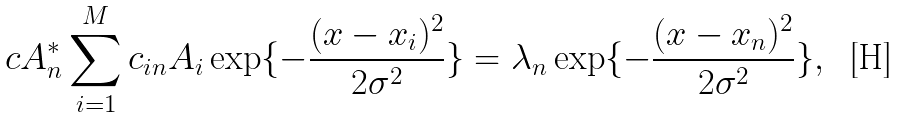Convert formula to latex. <formula><loc_0><loc_0><loc_500><loc_500>c A _ { n } ^ { * } \sum _ { i = 1 } ^ { M } c _ { i n } A _ { i } \exp \{ - \frac { ( x - x _ { i } ) ^ { 2 } } { 2 \sigma ^ { 2 } } \} = \lambda _ { n } \exp \{ - \frac { ( x - x _ { n } ) ^ { 2 } } { 2 \sigma ^ { 2 } } \} ,</formula> 